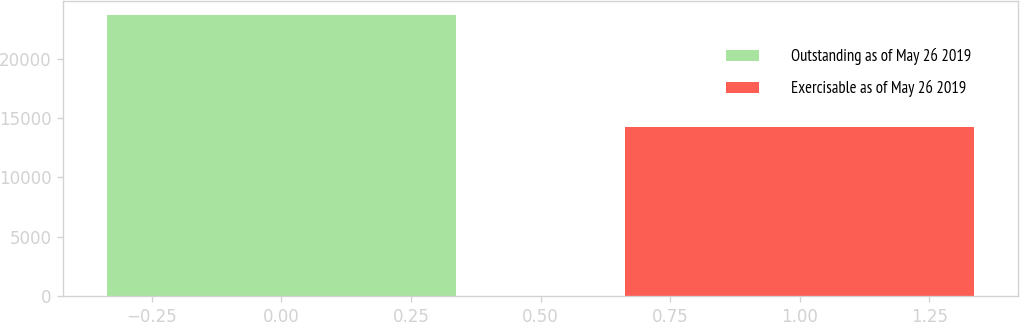Convert chart to OTSL. <chart><loc_0><loc_0><loc_500><loc_500><bar_chart><fcel>Outstanding as of May 26 2019<fcel>Exercisable as of May 26 2019<nl><fcel>23653<fcel>14219<nl></chart> 